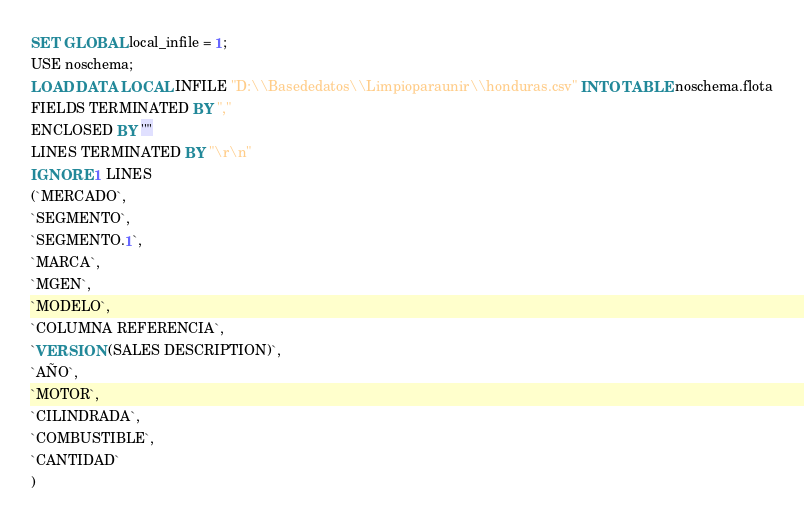<code> <loc_0><loc_0><loc_500><loc_500><_SQL_>SET GLOBAL local_infile = 1;
USE noschema;
LOAD DATA LOCAL INFILE "D:\\Basededatos\\Limpioparaunir\\honduras.csv" INTO TABLE noschema.flota
FIELDS TERMINATED BY ","
ENCLOSED BY '"'
LINES TERMINATED BY "\r\n"
IGNORE 1 LINES
(`MERCADO`,
`SEGMENTO`,
`SEGMENTO.1`,
`MARCA`,
`MGEN`,
`MODELO`,
`COLUMNA REFERENCIA`,
`VERSION (SALES DESCRIPTION)`,
`AÑO`,
`MOTOR`,
`CILINDRADA`,
`COMBUSTIBLE`,
`CANTIDAD`
)
</code> 